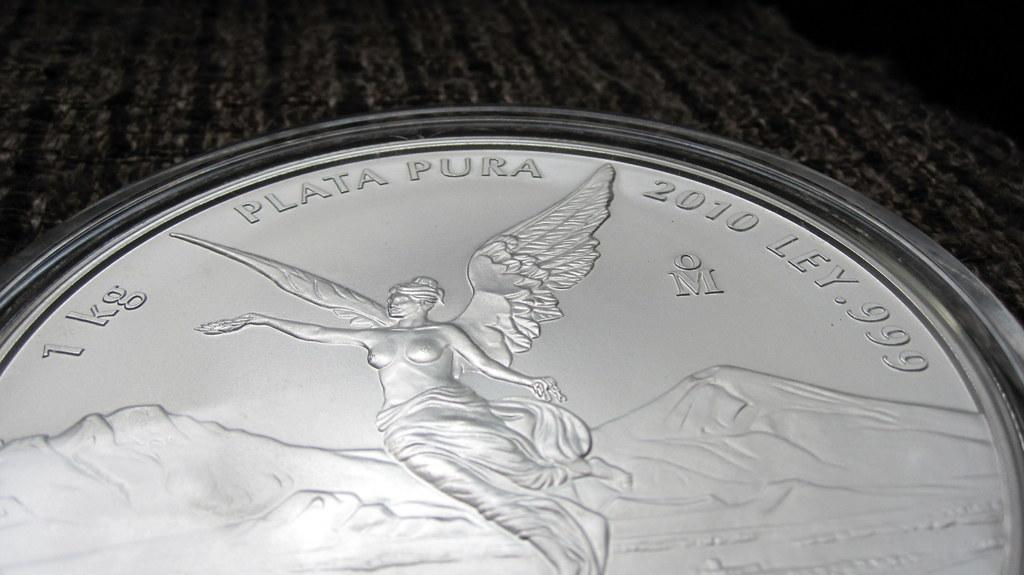<image>
Present a compact description of the photo's key features. a close up of a silver coin reading Plata Pura 1 kg 